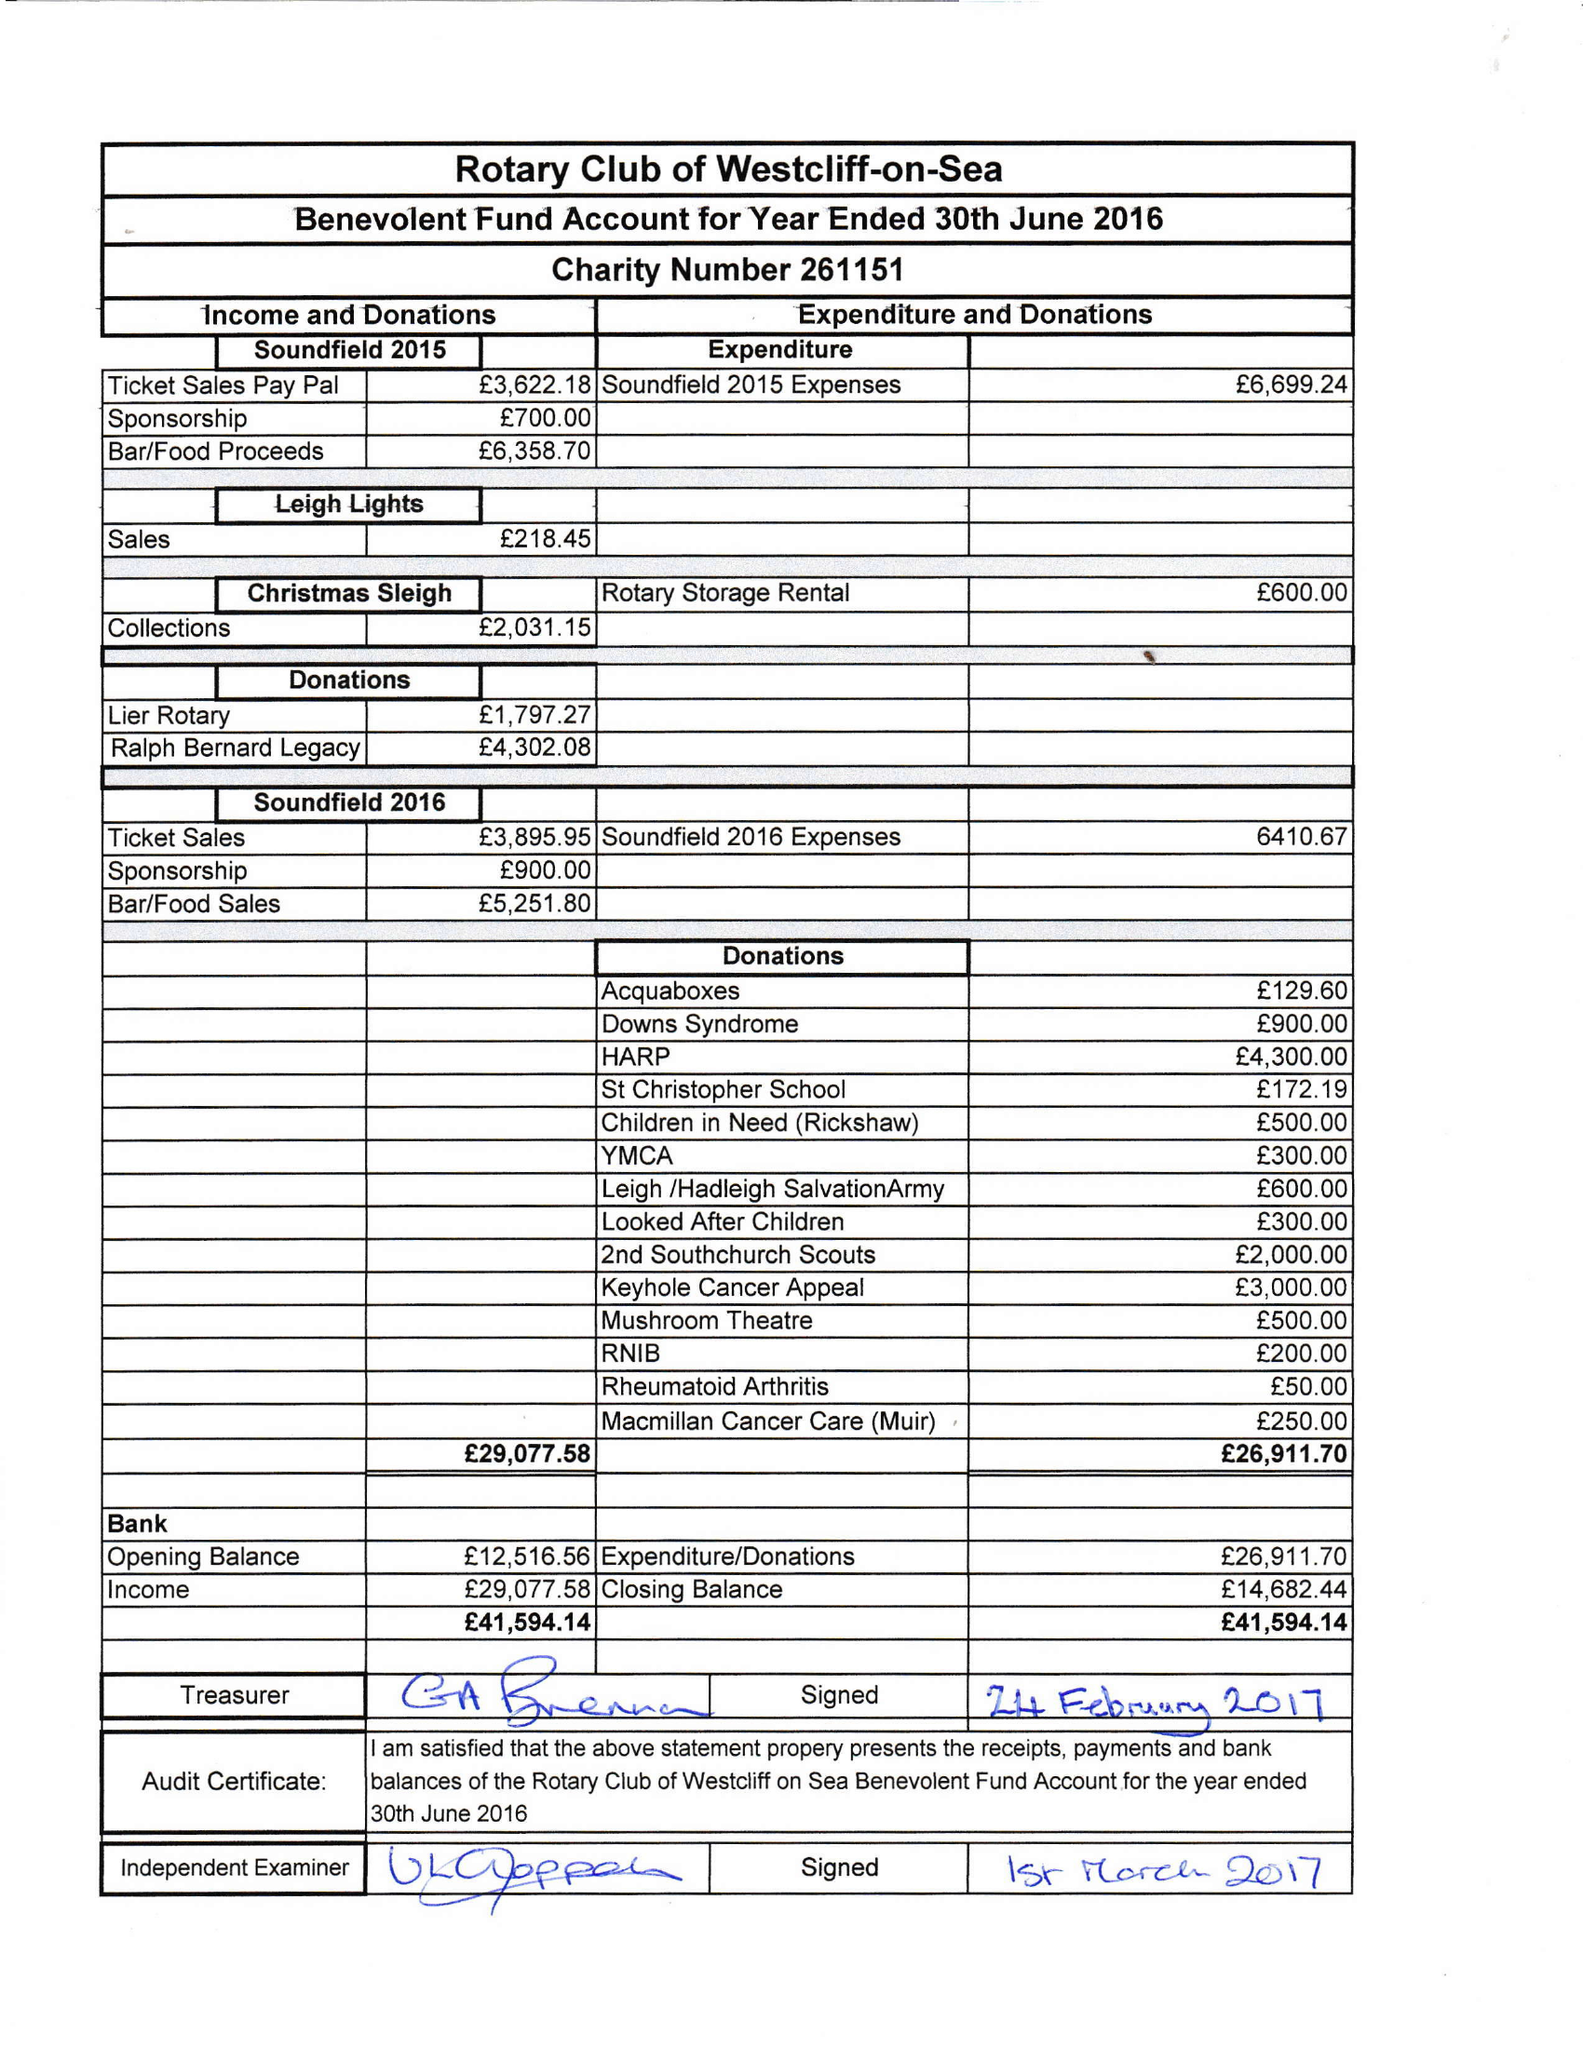What is the value for the charity_name?
Answer the question using a single word or phrase. Rotary Club Of Westcliff-On-Sea Benevolent Fund 